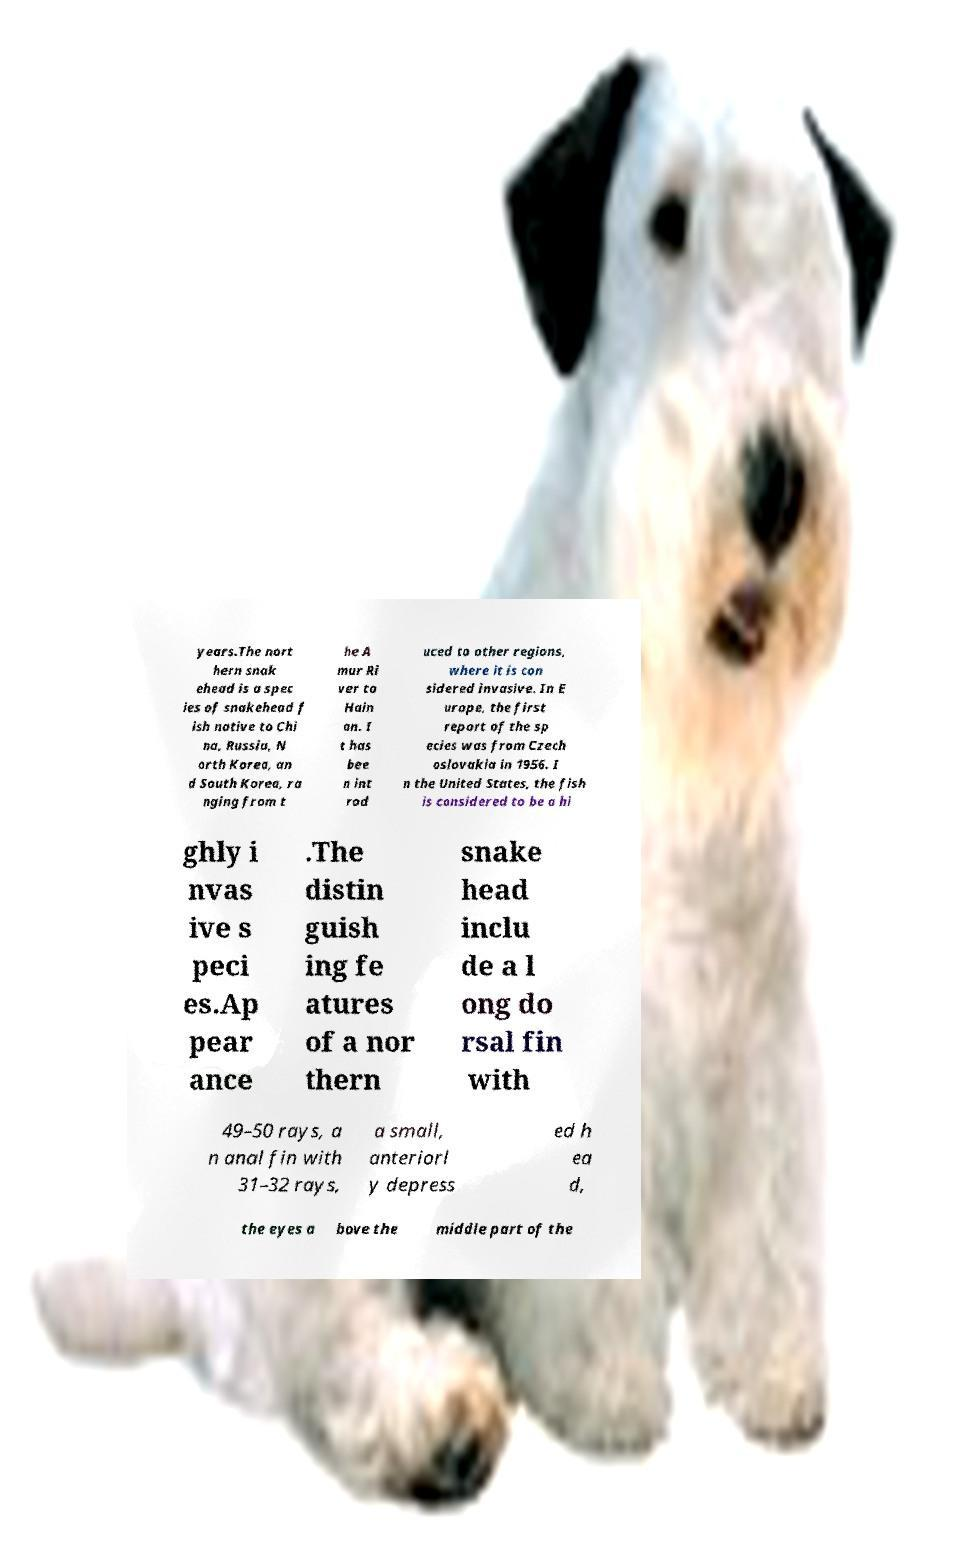Can you accurately transcribe the text from the provided image for me? years.The nort hern snak ehead is a spec ies of snakehead f ish native to Chi na, Russia, N orth Korea, an d South Korea, ra nging from t he A mur Ri ver to Hain an. I t has bee n int rod uced to other regions, where it is con sidered invasive. In E urope, the first report of the sp ecies was from Czech oslovakia in 1956. I n the United States, the fish is considered to be a hi ghly i nvas ive s peci es.Ap pear ance .The distin guish ing fe atures of a nor thern snake head inclu de a l ong do rsal fin with 49–50 rays, a n anal fin with 31–32 rays, a small, anteriorl y depress ed h ea d, the eyes a bove the middle part of the 